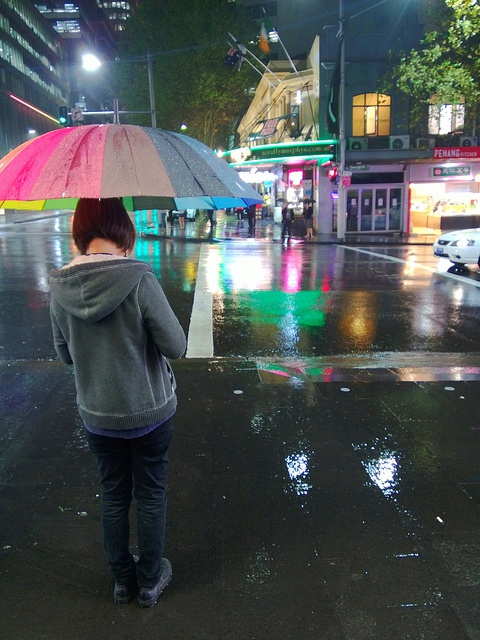Describe the objects in this image and their specific colors. I can see people in black, gray, and purple tones, umbrella in black, darkgray, violet, lightpink, and gray tones, car in black, white, lightblue, and darkgray tones, people in black, gray, and white tones, and people in black and gray tones in this image. 